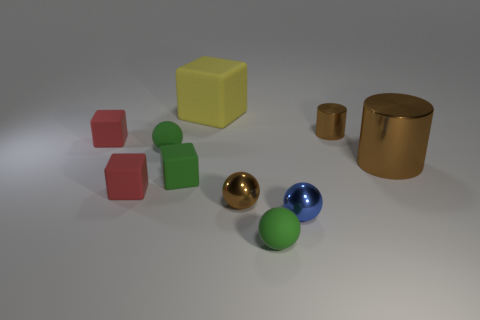Subtract 1 blocks. How many blocks are left? 3 Subtract all cylinders. How many objects are left? 8 Subtract 0 blue cubes. How many objects are left? 10 Subtract all cyan metallic blocks. Subtract all large cubes. How many objects are left? 9 Add 5 big metal things. How many big metal things are left? 6 Add 1 large red shiny objects. How many large red shiny objects exist? 1 